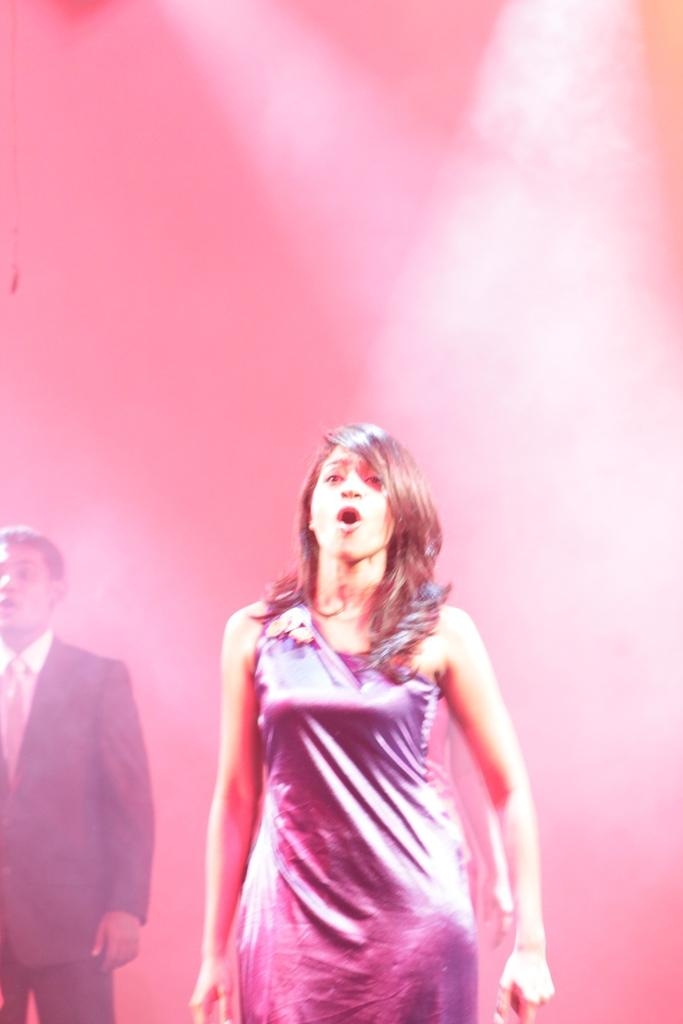Who is the main subject in the center of the image? There is a girl in the center of the image. Can you describe the other person in the image? There is a boy on the left side of the image. What type of print can be seen on the girl's shirt in the image? There is no information about the girl's shirt or any print on it in the provided facts. 